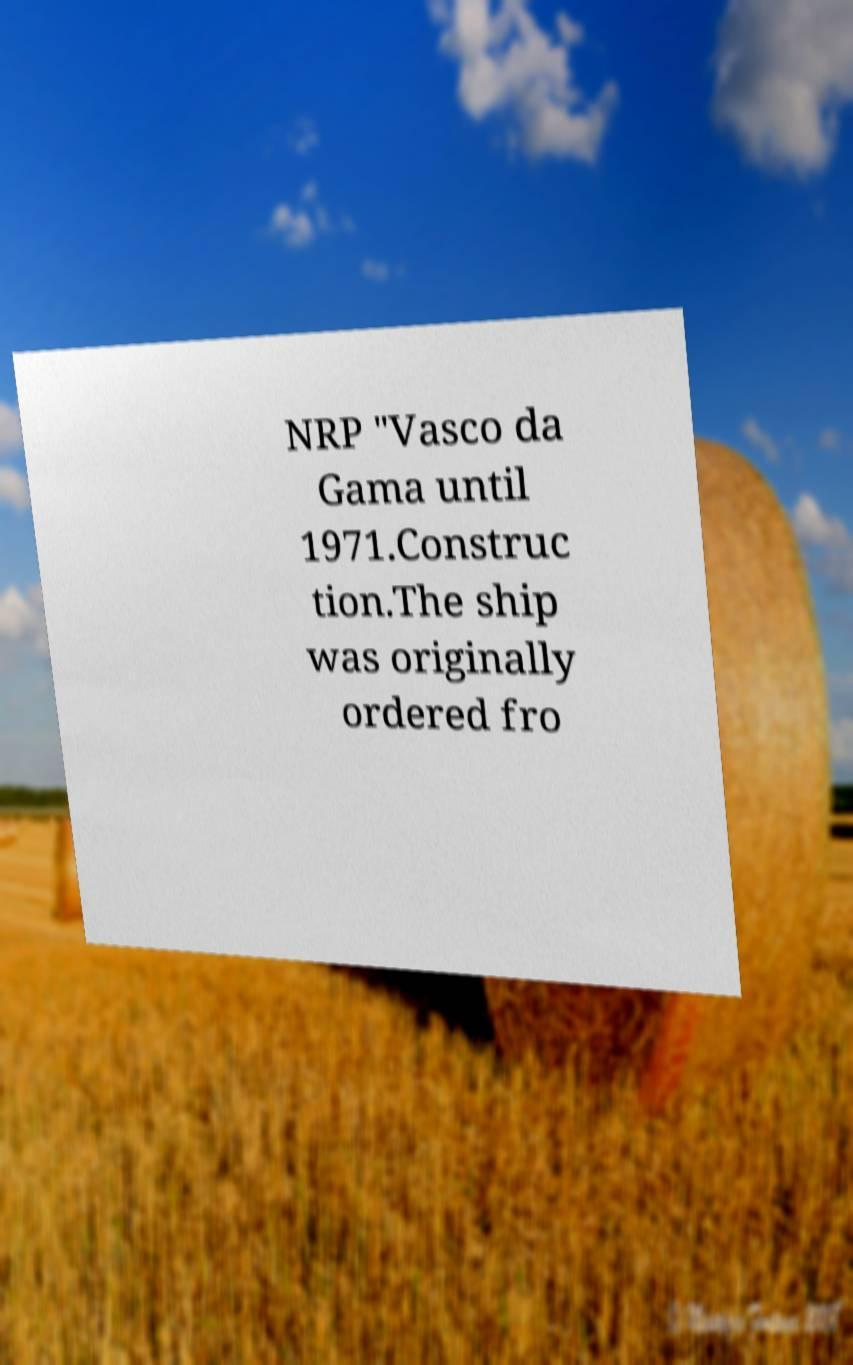Can you accurately transcribe the text from the provided image for me? NRP "Vasco da Gama until 1971.Construc tion.The ship was originally ordered fro 